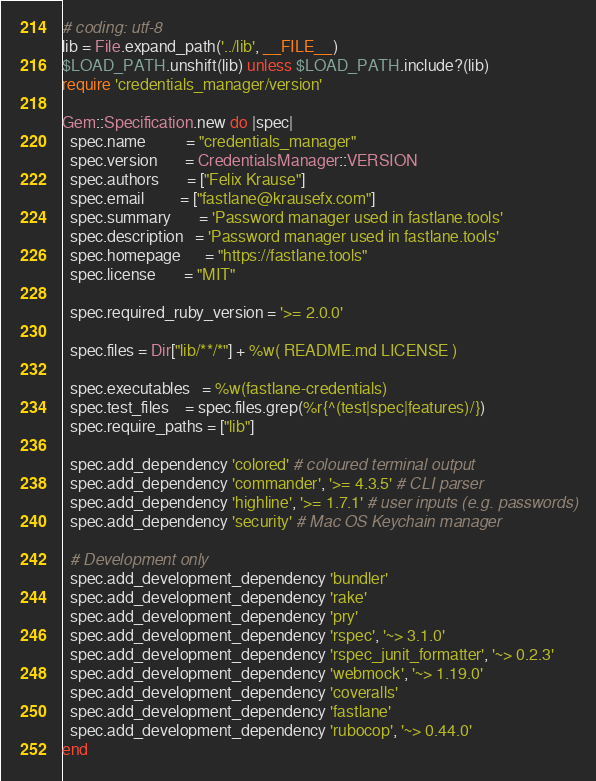Convert code to text. <code><loc_0><loc_0><loc_500><loc_500><_Ruby_># coding: utf-8
lib = File.expand_path('../lib', __FILE__)
$LOAD_PATH.unshift(lib) unless $LOAD_PATH.include?(lib)
require 'credentials_manager/version'

Gem::Specification.new do |spec|
  spec.name          = "credentials_manager"
  spec.version       = CredentialsManager::VERSION
  spec.authors       = ["Felix Krause"]
  spec.email         = ["fastlane@krausefx.com"]
  spec.summary       = 'Password manager used in fastlane.tools'
  spec.description   = 'Password manager used in fastlane.tools'
  spec.homepage      = "https://fastlane.tools"
  spec.license       = "MIT"

  spec.required_ruby_version = '>= 2.0.0'

  spec.files = Dir["lib/**/*"] + %w( README.md LICENSE )

  spec.executables   = %w(fastlane-credentials)
  spec.test_files    = spec.files.grep(%r{^(test|spec|features)/})
  spec.require_paths = ["lib"]

  spec.add_dependency 'colored' # coloured terminal output
  spec.add_dependency 'commander', '>= 4.3.5' # CLI parser
  spec.add_dependency 'highline', '>= 1.7.1' # user inputs (e.g. passwords)
  spec.add_dependency 'security' # Mac OS Keychain manager

  # Development only
  spec.add_development_dependency 'bundler'
  spec.add_development_dependency 'rake'
  spec.add_development_dependency 'pry'
  spec.add_development_dependency 'rspec', '~> 3.1.0'
  spec.add_development_dependency 'rspec_junit_formatter', '~> 0.2.3'
  spec.add_development_dependency 'webmock', '~> 1.19.0'
  spec.add_development_dependency 'coveralls'
  spec.add_development_dependency 'fastlane'
  spec.add_development_dependency 'rubocop', '~> 0.44.0'
end
</code> 